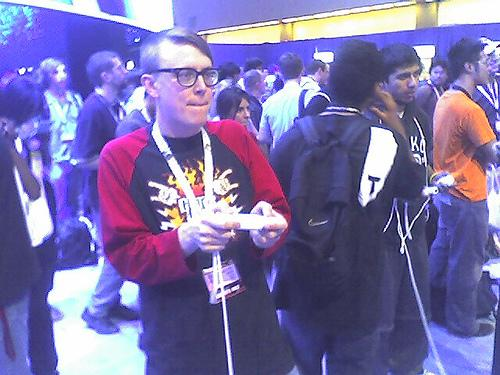What is the man in the black glasses using the white remote to do?

Choices:
A) power tv
B) open door
C) play games
D) control robot play games 